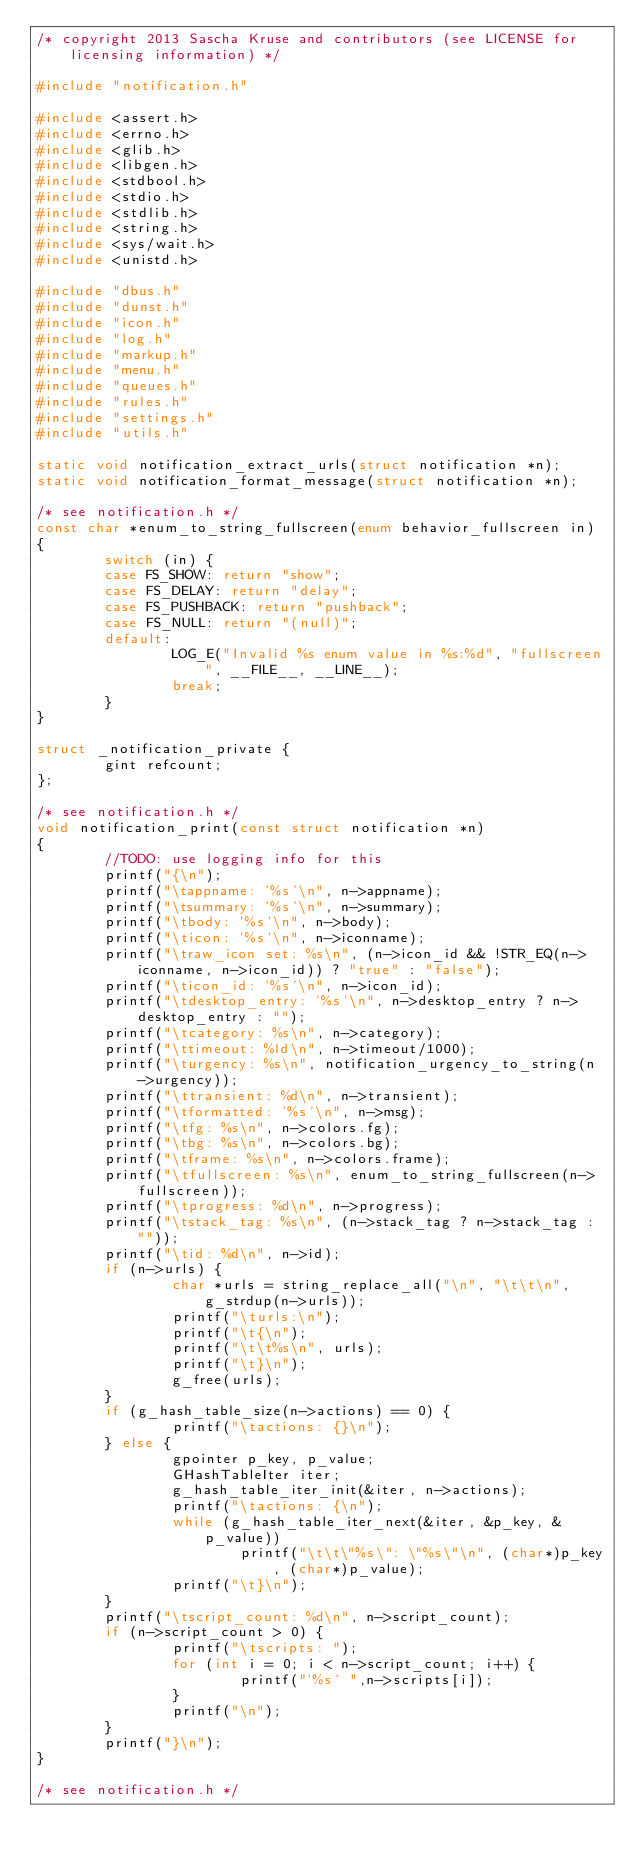<code> <loc_0><loc_0><loc_500><loc_500><_C_>/* copyright 2013 Sascha Kruse and contributors (see LICENSE for licensing information) */

#include "notification.h"

#include <assert.h>
#include <errno.h>
#include <glib.h>
#include <libgen.h>
#include <stdbool.h>
#include <stdio.h>
#include <stdlib.h>
#include <string.h>
#include <sys/wait.h>
#include <unistd.h>

#include "dbus.h"
#include "dunst.h"
#include "icon.h"
#include "log.h"
#include "markup.h"
#include "menu.h"
#include "queues.h"
#include "rules.h"
#include "settings.h"
#include "utils.h"

static void notification_extract_urls(struct notification *n);
static void notification_format_message(struct notification *n);

/* see notification.h */
const char *enum_to_string_fullscreen(enum behavior_fullscreen in)
{
        switch (in) {
        case FS_SHOW: return "show";
        case FS_DELAY: return "delay";
        case FS_PUSHBACK: return "pushback";
        case FS_NULL: return "(null)";
        default:
                LOG_E("Invalid %s enum value in %s:%d", "fullscreen", __FILE__, __LINE__);
                break;
        }
}

struct _notification_private {
        gint refcount;
};

/* see notification.h */
void notification_print(const struct notification *n)
{
        //TODO: use logging info for this
        printf("{\n");
        printf("\tappname: '%s'\n", n->appname);
        printf("\tsummary: '%s'\n", n->summary);
        printf("\tbody: '%s'\n", n->body);
        printf("\ticon: '%s'\n", n->iconname);
        printf("\traw_icon set: %s\n", (n->icon_id && !STR_EQ(n->iconname, n->icon_id)) ? "true" : "false");
        printf("\ticon_id: '%s'\n", n->icon_id);
        printf("\tdesktop_entry: '%s'\n", n->desktop_entry ? n->desktop_entry : "");
        printf("\tcategory: %s\n", n->category);
        printf("\ttimeout: %ld\n", n->timeout/1000);
        printf("\turgency: %s\n", notification_urgency_to_string(n->urgency));
        printf("\ttransient: %d\n", n->transient);
        printf("\tformatted: '%s'\n", n->msg);
        printf("\tfg: %s\n", n->colors.fg);
        printf("\tbg: %s\n", n->colors.bg);
        printf("\tframe: %s\n", n->colors.frame);
        printf("\tfullscreen: %s\n", enum_to_string_fullscreen(n->fullscreen));
        printf("\tprogress: %d\n", n->progress);
        printf("\tstack_tag: %s\n", (n->stack_tag ? n->stack_tag : ""));
        printf("\tid: %d\n", n->id);
        if (n->urls) {
                char *urls = string_replace_all("\n", "\t\t\n", g_strdup(n->urls));
                printf("\turls:\n");
                printf("\t{\n");
                printf("\t\t%s\n", urls);
                printf("\t}\n");
                g_free(urls);
        }
        if (g_hash_table_size(n->actions) == 0) {
                printf("\tactions: {}\n");
        } else {
                gpointer p_key, p_value;
                GHashTableIter iter;
                g_hash_table_iter_init(&iter, n->actions);
                printf("\tactions: {\n");
                while (g_hash_table_iter_next(&iter, &p_key, &p_value))
                        printf("\t\t\"%s\": \"%s\"\n", (char*)p_key, (char*)p_value);
                printf("\t}\n");
        }
        printf("\tscript_count: %d\n", n->script_count);
        if (n->script_count > 0) {
                printf("\tscripts: ");
                for (int i = 0; i < n->script_count; i++) {
                        printf("'%s' ",n->scripts[i]);
                }
                printf("\n");
        }
        printf("}\n");
}

/* see notification.h */</code> 